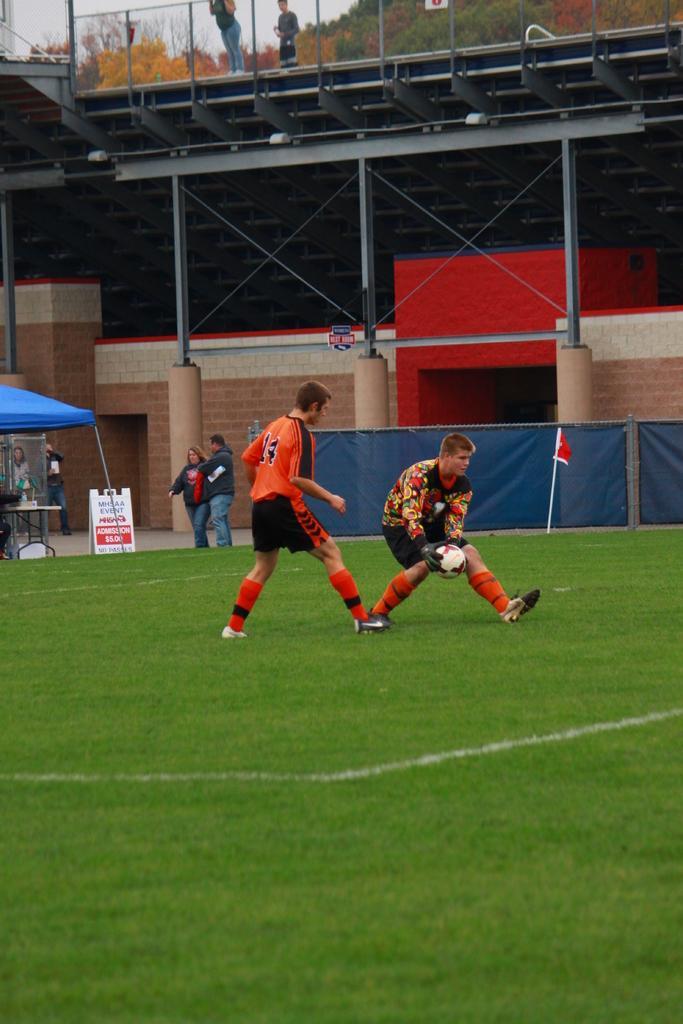Can you describe this image briefly? There are two men playing with a ball in the ground. There are some people standing in the background and we can observe a flag and a fence here. There is a stadium and some trees here. 